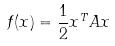<formula> <loc_0><loc_0><loc_500><loc_500>f ( x ) = \frac { 1 } { 2 } x ^ { T } A x</formula> 